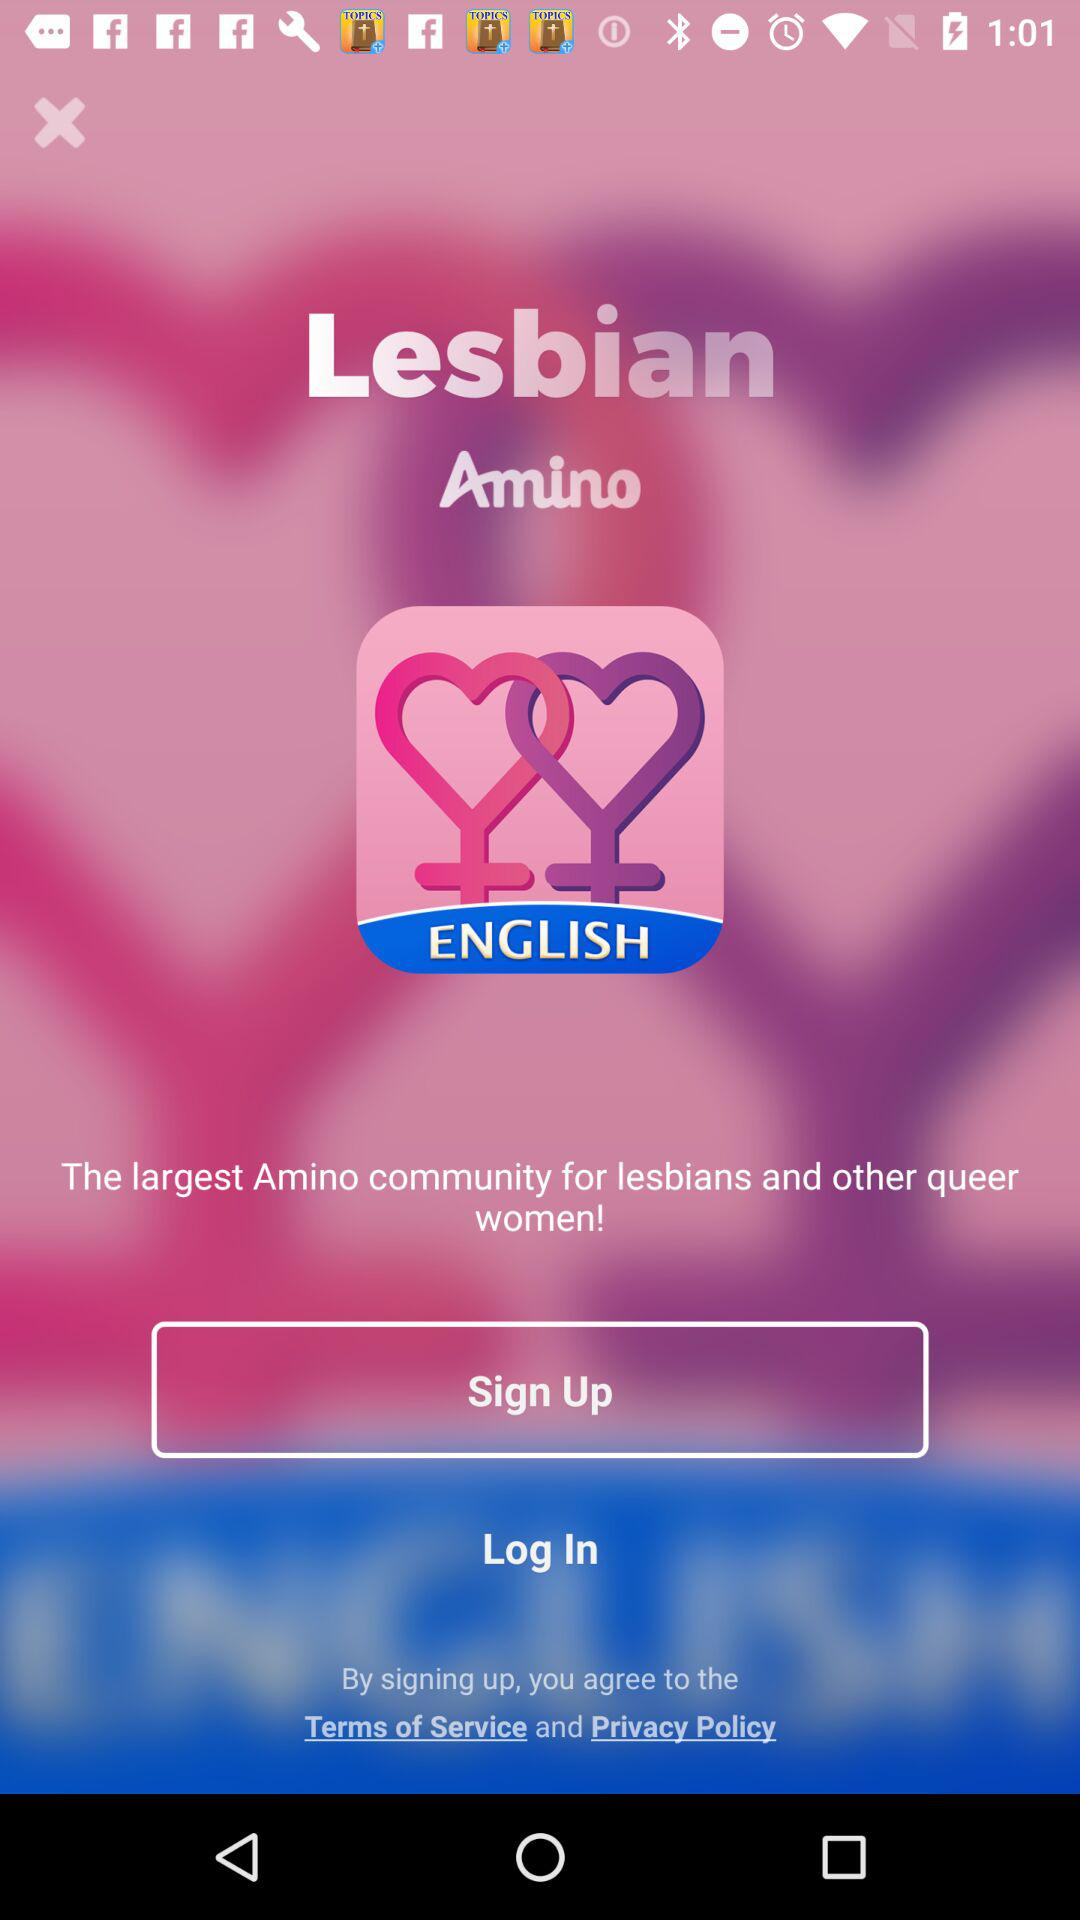What is the name of the application? The name of the application is "Amino". 